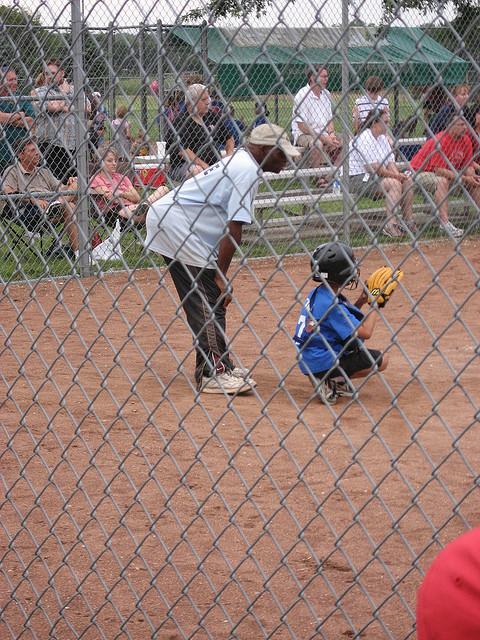What color is the fence?
Concise answer only. Silver. What color is the boy's jersey?
Quick response, please. Blue. What position is the little boy playing?
Write a very short answer. Catcher. How many benches are there for the crowd to sit on?
Answer briefly. 3. Where is the chain-link fence?
Answer briefly. Behind players. Is this child batting?
Be succinct. No. 